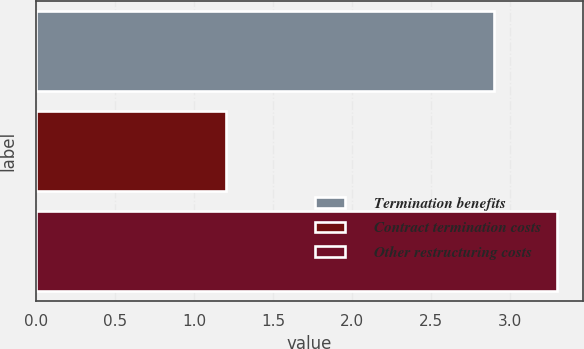<chart> <loc_0><loc_0><loc_500><loc_500><bar_chart><fcel>Termination benefits<fcel>Contract termination costs<fcel>Other restructuring costs<nl><fcel>2.9<fcel>1.2<fcel>3.3<nl></chart> 